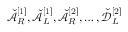<formula> <loc_0><loc_0><loc_500><loc_500>\check { \mathcal { A } } _ { R } ^ { [ 1 ] } , \check { \mathcal { A } } _ { L } ^ { [ 1 ] } , \check { \mathcal { A } } _ { R } ^ { [ 2 ] } , \dots , \check { \mathcal { D } } _ { L } ^ { [ 2 ] }</formula> 